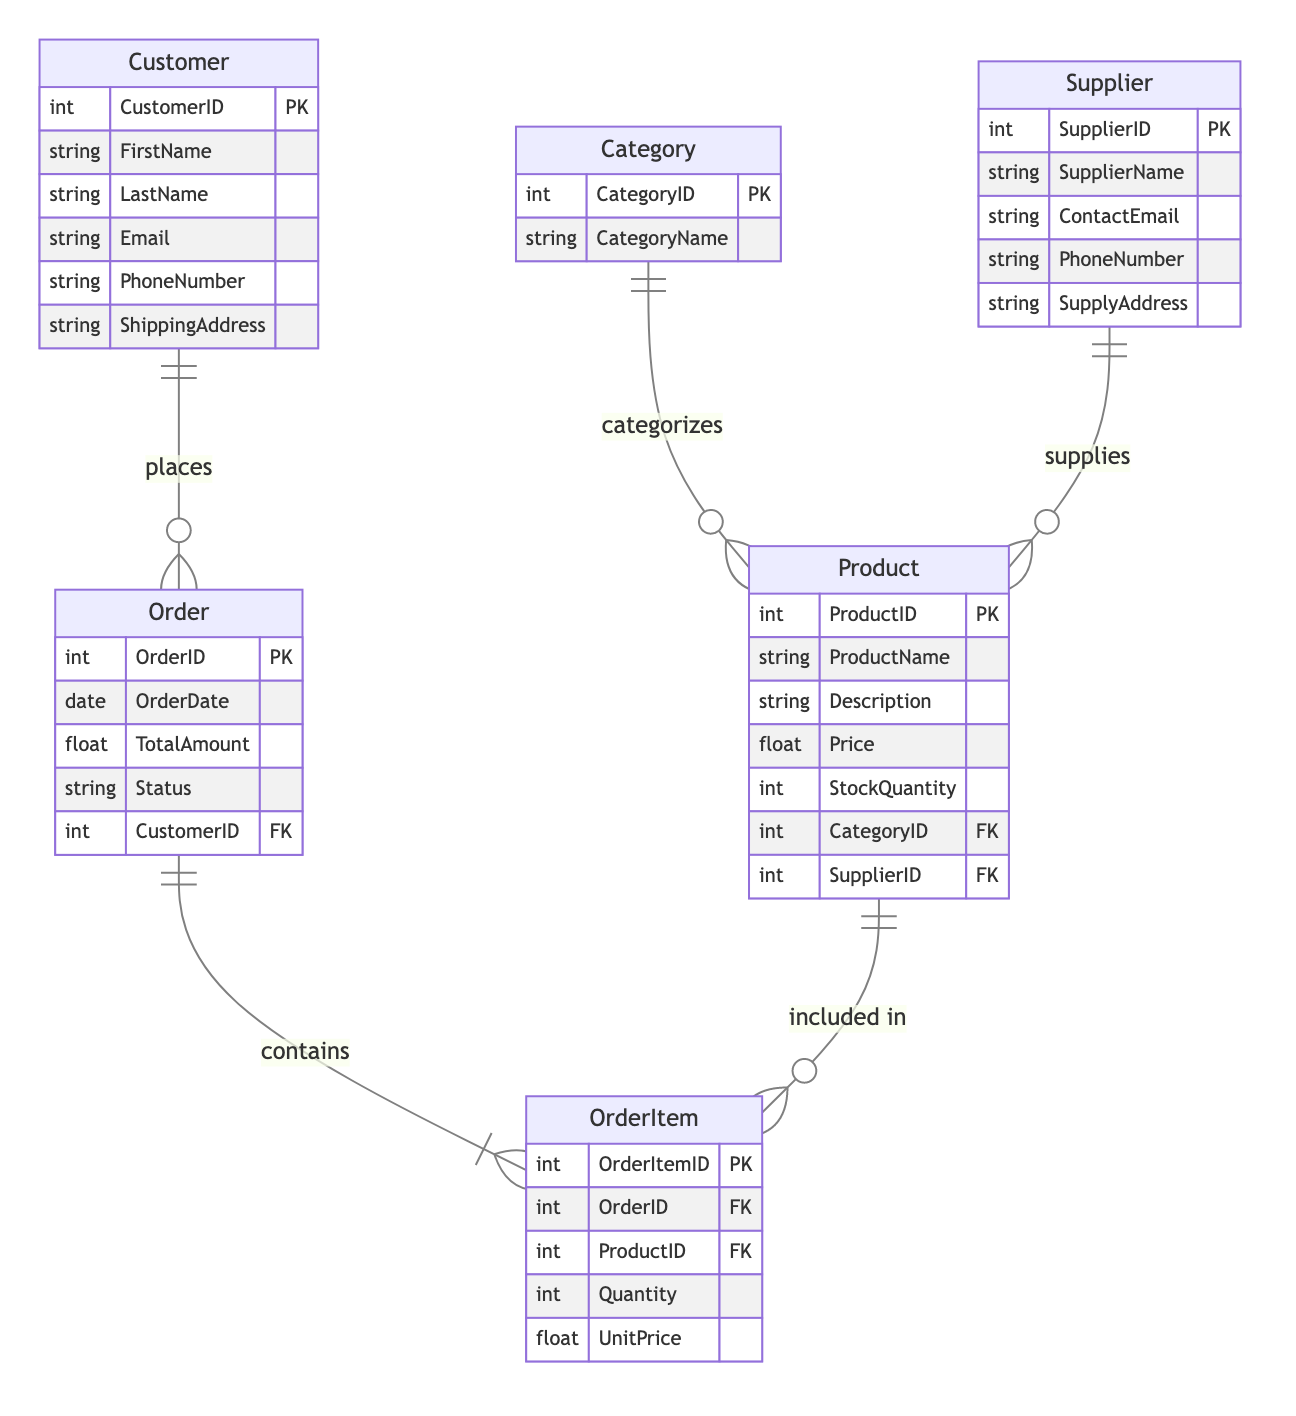What is the primary key of the Customer entity? The primary key is identified by "PK" next to the attribute name in the Customer entity. In this case, "CustomerID" is marked as the primary key.
Answer: CustomerID How many attributes does the Product entity have? The Product entity lists six attributes: ProductID, ProductName, Description, Price, StockQuantity, and CategoryID. Counting these gives a total of six attributes.
Answer: 6 Which entity represents the relationship of a customer placing an order? The diagram indicates a one-to-many relationship between the Customer and Order entities, identified as "CustomerOrder." This shows that a Customer can place multiple Orders.
Answer: Order What relationship does the OrderItem entity have with the Order entity? The relationship is one-to-many, denoted by the connection between Order and OrderItem. This indicates that each Order can contain multiple OrderItems.
Answer: contains How many entities are there in total in the diagram? The entities listed are Customer, Order, Product, OrderItem, Category, and Supplier. Counting these gives a total of six entities.
Answer: 6 Which entity supplies products to the Product entity? The Supplier entity has a one-to-many relationship with the Product entity, indicating that a Supplier can supply many Products. This relationship is labeled as "SupplierProduct."
Answer: Supplier What attribute links the Order and OrderItem entities? The foreign key "OrderID" in the OrderItem entity links it to the Order entity, allowing an association between them.
Answer: OrderID Which entity categories products in the system? The Category entity categorizes products, as shown by the one-to-many relationship with the Product entity labeled "CategoryProduct." This means each category can consist of multiple products.
Answer: Category What is the role of the OrderItemID in the OrderItem entity? The OrderItemID serves as the primary key (PK) for the OrderItem entity, uniquely identifying each order item in the system.
Answer: Primary key 